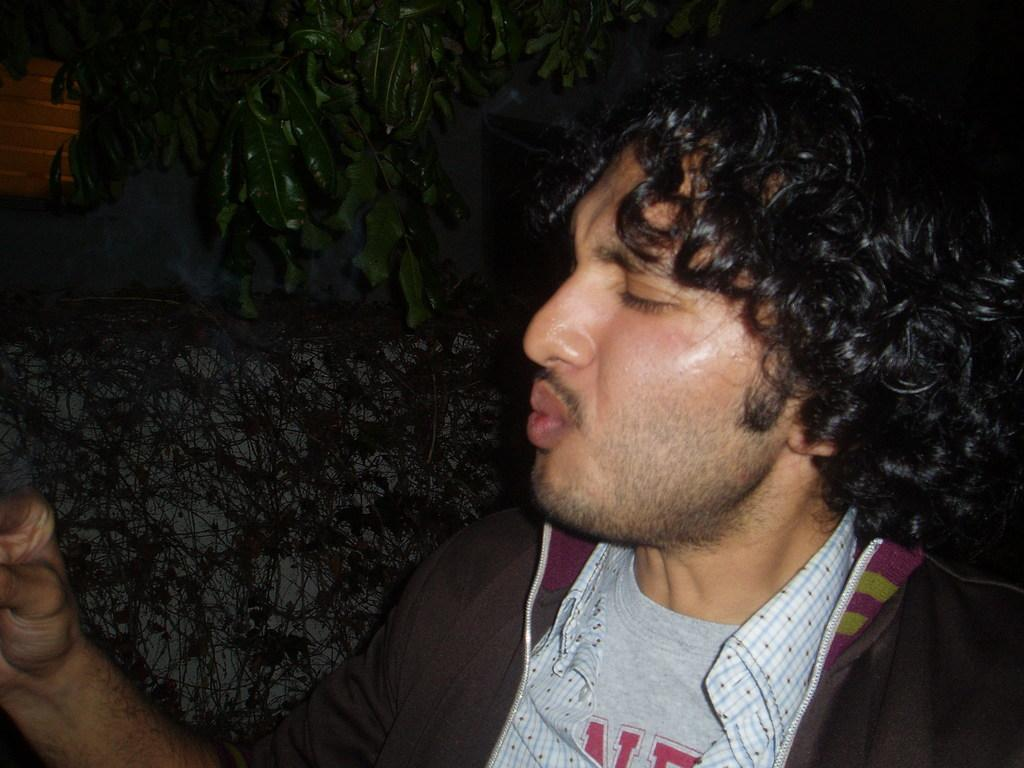What is the main subject of the image? There is a person standing in the image. What can be seen in the background of the image? There are trees in the background of the image. What type of alarm can be heard going off in the image? There is no alarm present in the image, and therefore no such sound can be heard. 